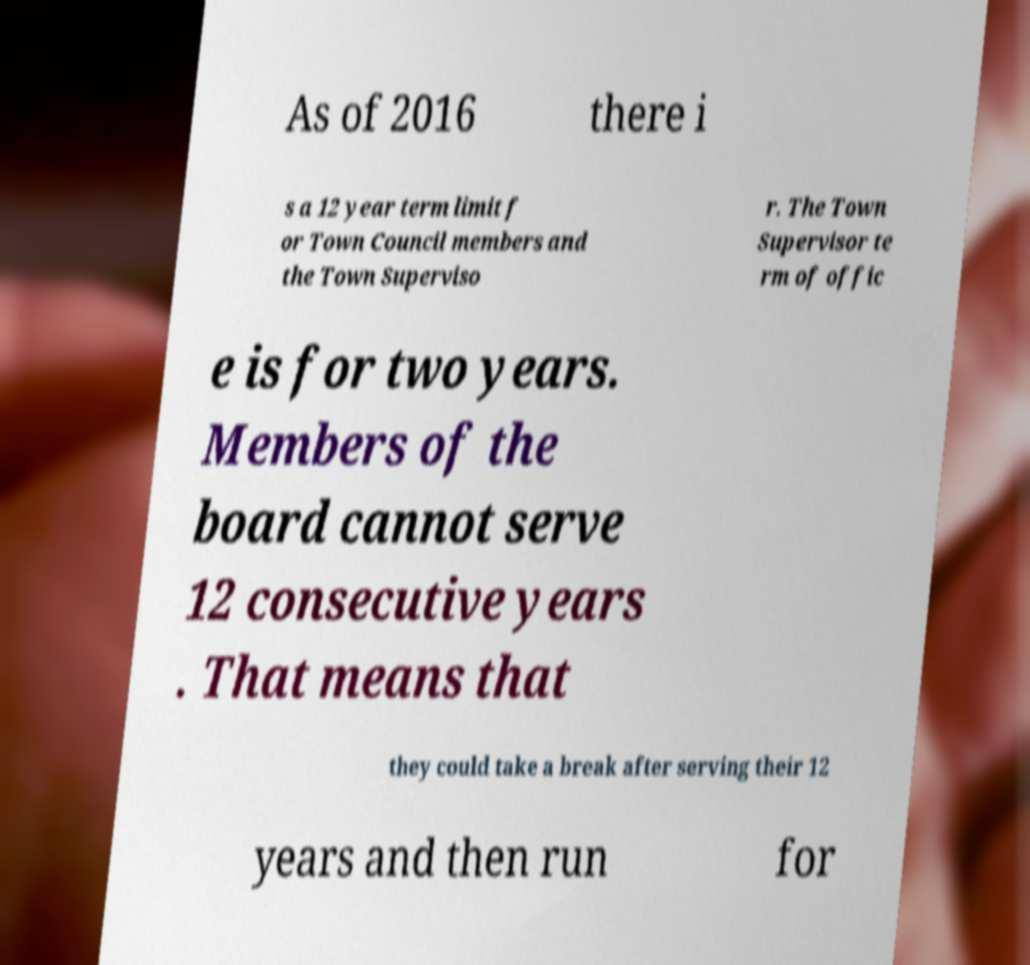Please read and relay the text visible in this image. What does it say? As of 2016 there i s a 12 year term limit f or Town Council members and the Town Superviso r. The Town Supervisor te rm of offic e is for two years. Members of the board cannot serve 12 consecutive years . That means that they could take a break after serving their 12 years and then run for 